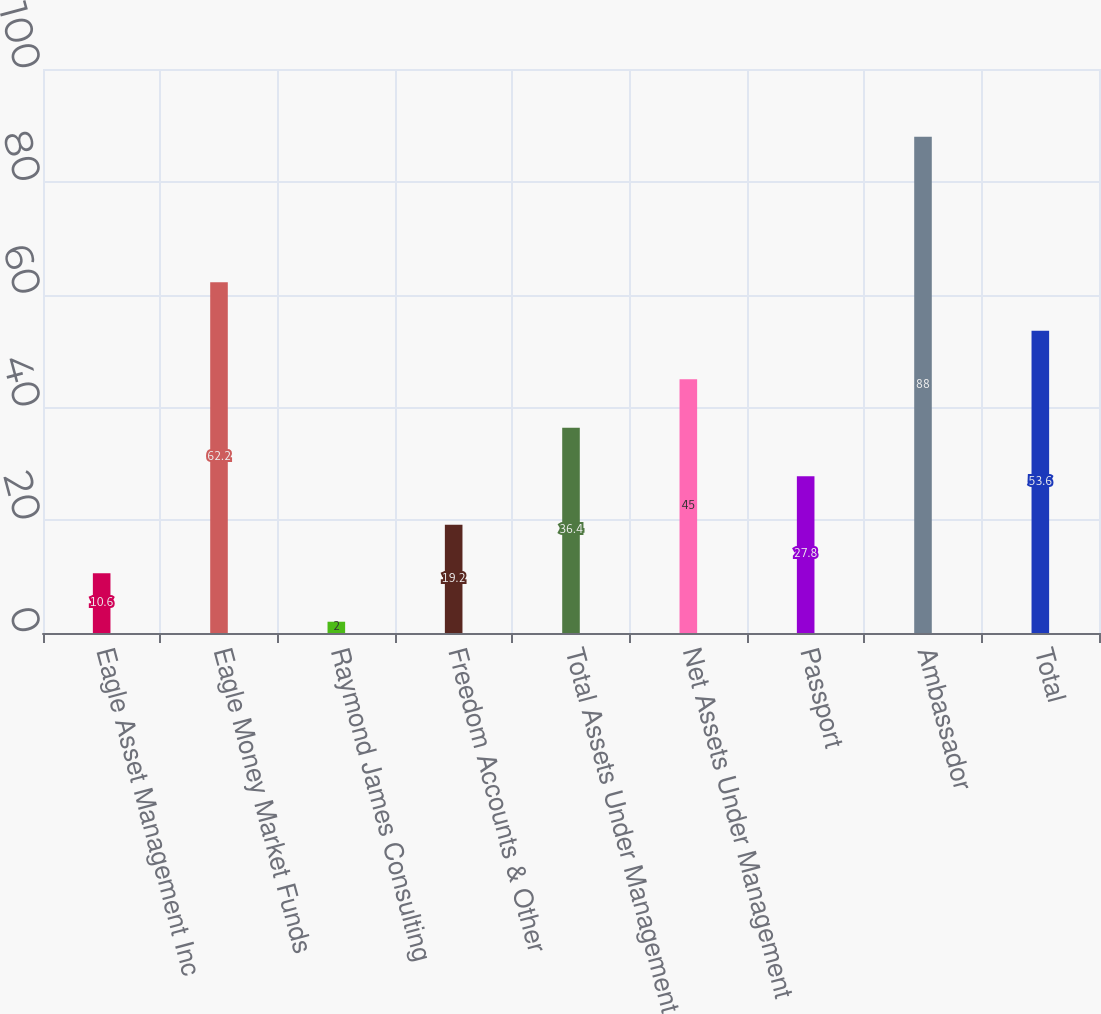<chart> <loc_0><loc_0><loc_500><loc_500><bar_chart><fcel>Eagle Asset Management Inc<fcel>Eagle Money Market Funds<fcel>Raymond James Consulting<fcel>Freedom Accounts & Other<fcel>Total Assets Under Management<fcel>Net Assets Under Management<fcel>Passport<fcel>Ambassador<fcel>Total<nl><fcel>10.6<fcel>62.2<fcel>2<fcel>19.2<fcel>36.4<fcel>45<fcel>27.8<fcel>88<fcel>53.6<nl></chart> 